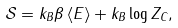<formula> <loc_0><loc_0><loc_500><loc_500>\mathcal { S } = k _ { B } \beta \left \langle E \right \rangle + k _ { B } \log Z _ { C } ,</formula> 